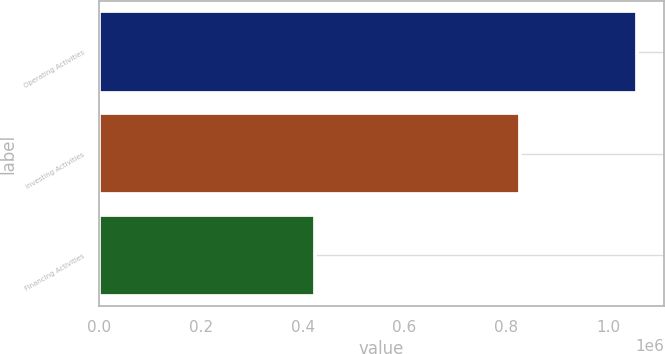Convert chart. <chart><loc_0><loc_0><loc_500><loc_500><bar_chart><fcel>Operating Activities<fcel>Investing Activities<fcel>Financing Activities<nl><fcel>1.05673e+06<fcel>825579<fcel>425117<nl></chart> 